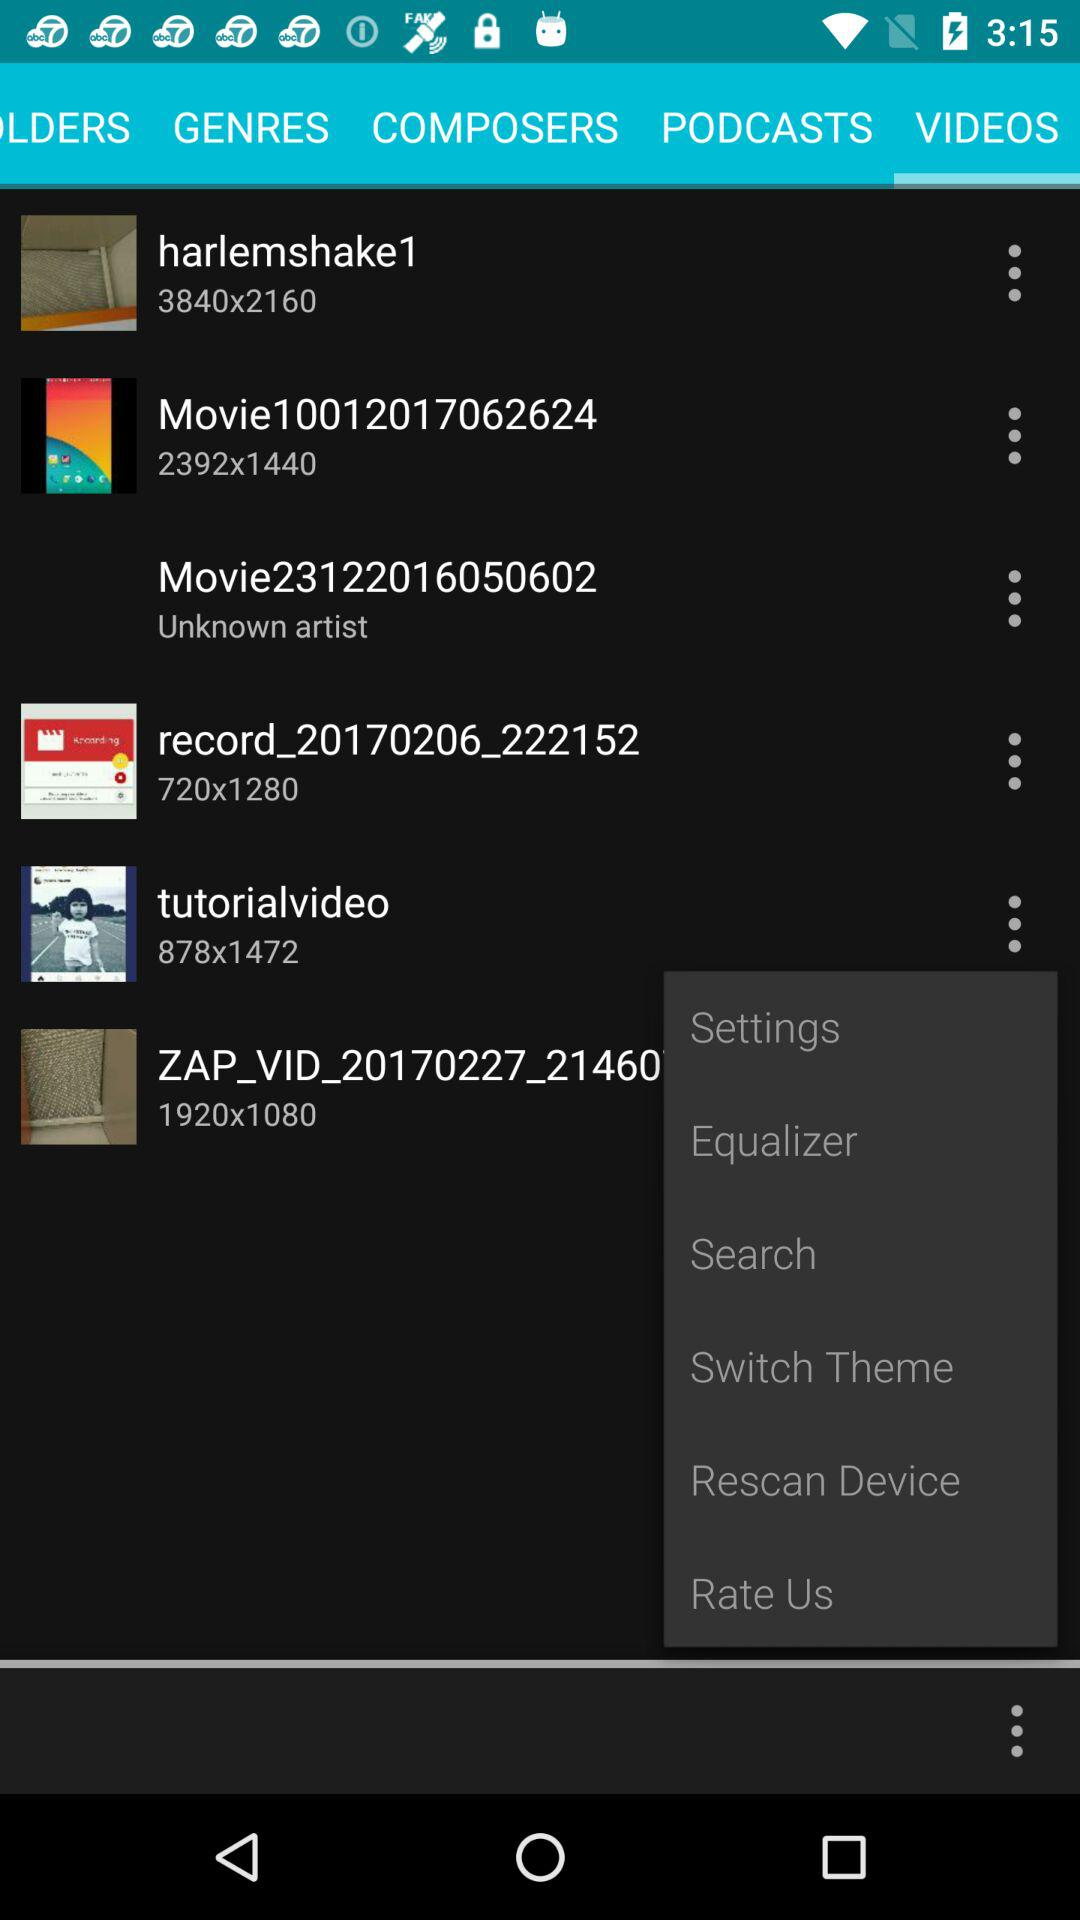What is the pixel size of the video "tutorialvideo"? The pixel size is 878×1472. 